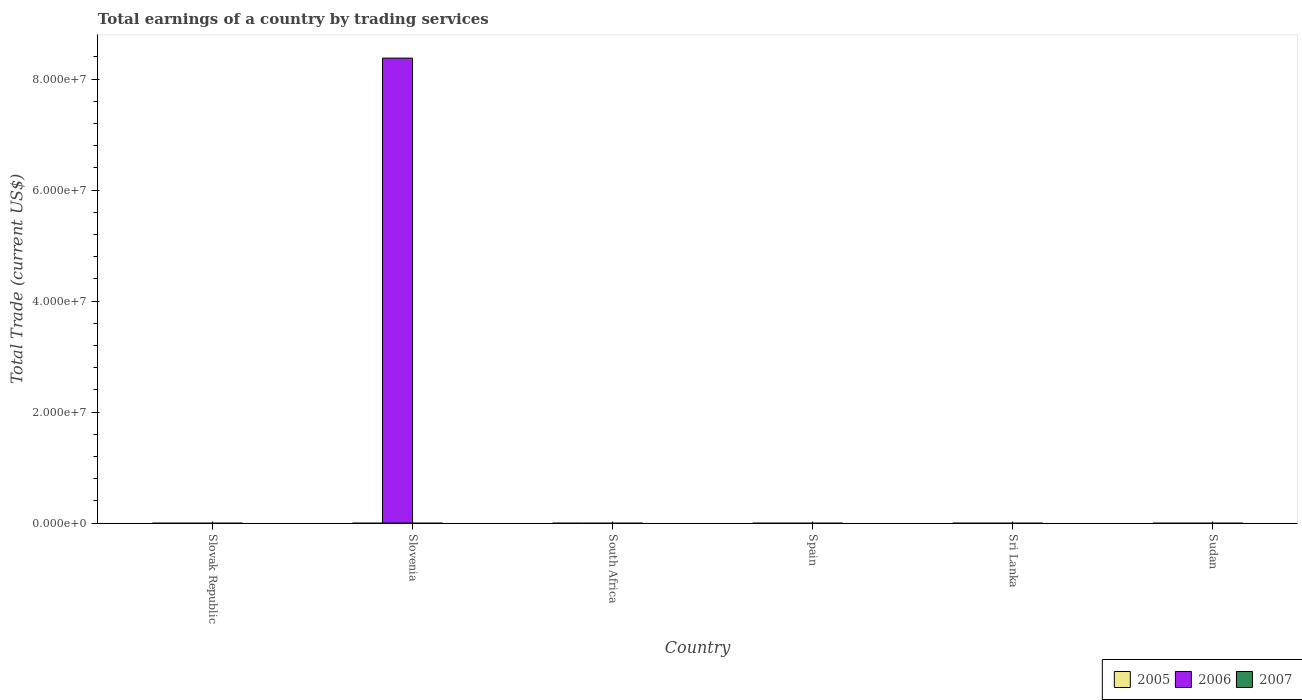How many different coloured bars are there?
Your answer should be very brief. 1. Are the number of bars per tick equal to the number of legend labels?
Provide a succinct answer. No. How many bars are there on the 5th tick from the left?
Provide a succinct answer. 0. What is the label of the 5th group of bars from the left?
Provide a short and direct response. Sri Lanka. What is the total earnings in 2005 in Slovak Republic?
Keep it short and to the point. 0. Across all countries, what is the maximum total earnings in 2006?
Your answer should be very brief. 8.38e+07. Across all countries, what is the minimum total earnings in 2006?
Your answer should be very brief. 0. In which country was the total earnings in 2006 maximum?
Your answer should be compact. Slovenia. What is the total total earnings in 2006 in the graph?
Offer a very short reply. 8.38e+07. What is the difference between the total earnings in 2007 in South Africa and the total earnings in 2005 in Sudan?
Your answer should be very brief. 0. What is the average total earnings in 2005 per country?
Keep it short and to the point. 0. What is the difference between the highest and the lowest total earnings in 2006?
Your response must be concise. 8.38e+07. Are the values on the major ticks of Y-axis written in scientific E-notation?
Ensure brevity in your answer.  Yes. Does the graph contain any zero values?
Make the answer very short. Yes. Does the graph contain grids?
Your answer should be very brief. No. How are the legend labels stacked?
Provide a succinct answer. Horizontal. What is the title of the graph?
Your answer should be compact. Total earnings of a country by trading services. What is the label or title of the Y-axis?
Give a very brief answer. Total Trade (current US$). What is the Total Trade (current US$) in 2006 in Slovenia?
Make the answer very short. 8.38e+07. What is the Total Trade (current US$) in 2007 in Slovenia?
Offer a terse response. 0. What is the Total Trade (current US$) of 2005 in South Africa?
Provide a succinct answer. 0. What is the Total Trade (current US$) in 2006 in South Africa?
Your response must be concise. 0. What is the Total Trade (current US$) in 2007 in South Africa?
Offer a very short reply. 0. What is the Total Trade (current US$) of 2005 in Spain?
Your response must be concise. 0. What is the Total Trade (current US$) of 2006 in Spain?
Your answer should be compact. 0. What is the Total Trade (current US$) of 2007 in Spain?
Give a very brief answer. 0. What is the Total Trade (current US$) of 2005 in Sri Lanka?
Make the answer very short. 0. What is the Total Trade (current US$) in 2007 in Sri Lanka?
Your answer should be compact. 0. Across all countries, what is the maximum Total Trade (current US$) of 2006?
Give a very brief answer. 8.38e+07. Across all countries, what is the minimum Total Trade (current US$) in 2006?
Make the answer very short. 0. What is the total Total Trade (current US$) in 2005 in the graph?
Keep it short and to the point. 0. What is the total Total Trade (current US$) of 2006 in the graph?
Your response must be concise. 8.38e+07. What is the total Total Trade (current US$) of 2007 in the graph?
Ensure brevity in your answer.  0. What is the average Total Trade (current US$) of 2006 per country?
Provide a short and direct response. 1.40e+07. What is the difference between the highest and the lowest Total Trade (current US$) in 2006?
Make the answer very short. 8.38e+07. 